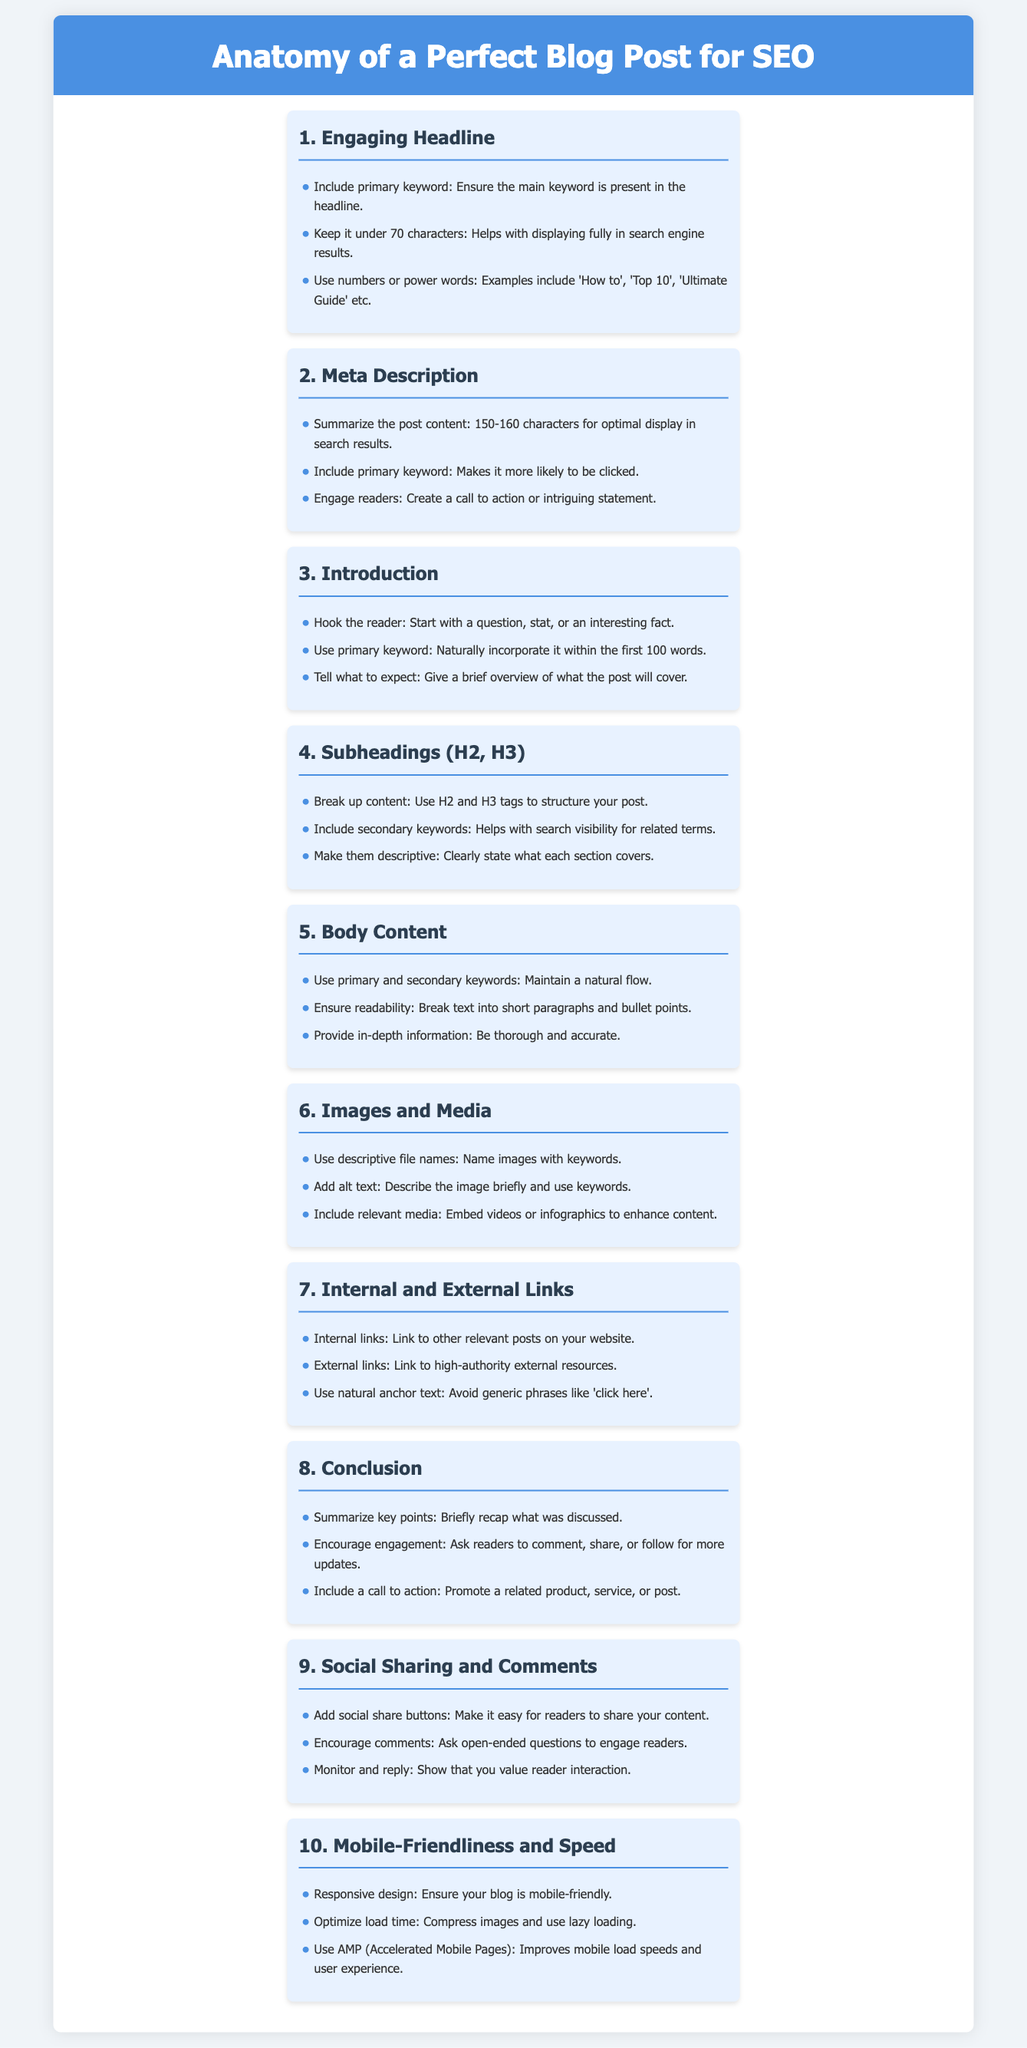What is the first component of a perfect blog post for SEO? The first component listed in the infographic is "Engaging Headline."
Answer: Engaging Headline What is the optimal length for a meta description? The document states that the optimal length for a meta description is between 150-160 characters.
Answer: 150-160 characters What should be included in subheadings? According to the document, subheadings should include secondary keywords.
Answer: Secondary keywords Which section encourages engagement with readers? The conclusion section is where readers are encouraged to engage through comments and shares.
Answer: Conclusion What is recommended for body content readability? The document suggests breaking text into short paragraphs and bullet points for readability.
Answer: Short paragraphs and bullet points What does the infographic suggest for images and media? It suggests using descriptive file names for images.
Answer: Descriptive file names How should internal and external links be handled? The document advises using natural anchor text instead of generic phrases.
Answer: Natural anchor text What is a feature of mobile-friendliness mentioned? Responsive design is mentioned as a feature of mobile-friendliness.
Answer: Responsive design How many sections are listed in the infographic? There are ten sections listed in the document.
Answer: Ten sections What action should be included in the call to action? The call to action should promote a related product, service, or post.
Answer: Promote a related product, service, or post 